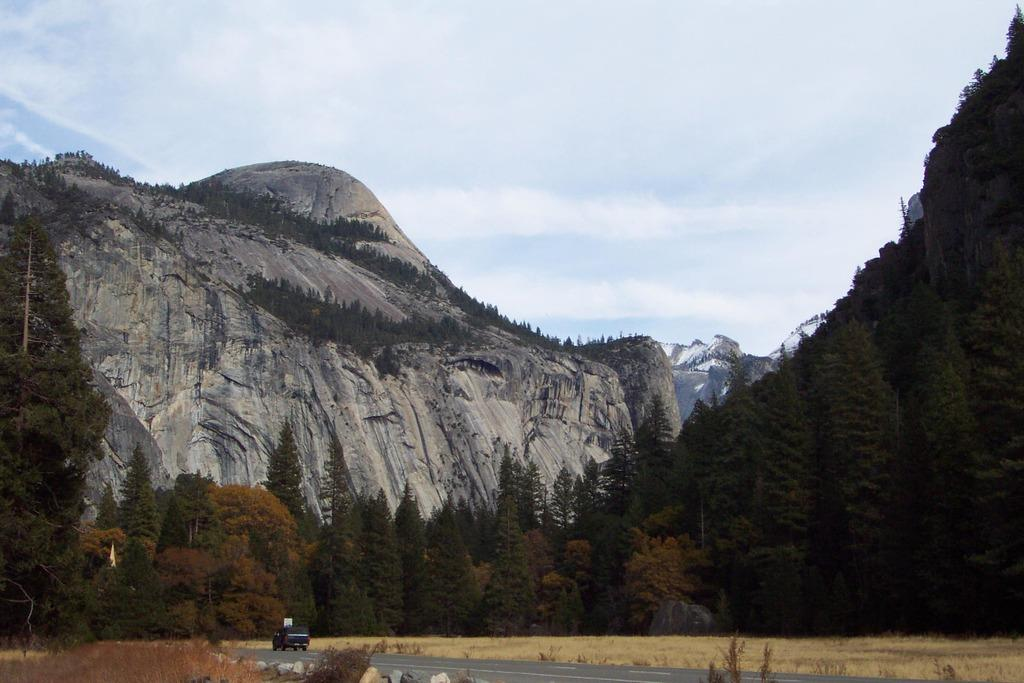What type of living organisms can be seen in the image? Plants can be seen in the image. What is happening on the road in the image? There is a vehicle moving on the road in the image. What can be seen in the background of the image? Trees and mountains are visible in the background of the image. How would you describe the sky in the image? The sky is cloudy in the image. What type of pleasure can be seen being derived from the meeting in the image? There is no meeting or pleasure present in the image; it features plants, a moving vehicle, trees, mountains, and a cloudy sky. How many times has the object been folded in the image? There is no object being folded in the image. 